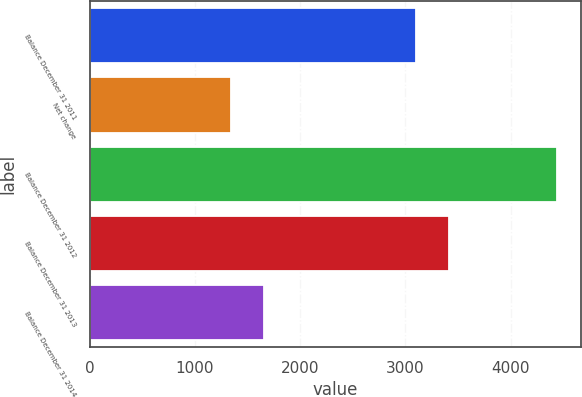<chart> <loc_0><loc_0><loc_500><loc_500><bar_chart><fcel>Balance December 31 2011<fcel>Net change<fcel>Balance December 31 2012<fcel>Balance December 31 2013<fcel>Balance December 31 2014<nl><fcel>3100<fcel>1343<fcel>4443<fcel>3410<fcel>1653<nl></chart> 